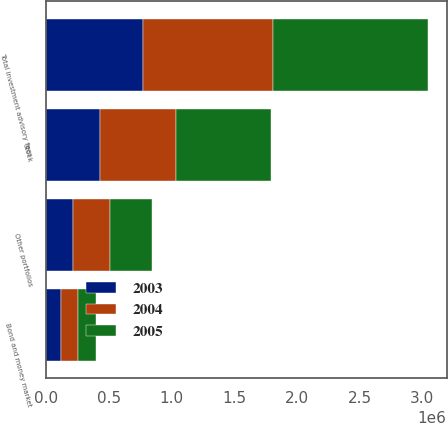Convert chart to OTSL. <chart><loc_0><loc_0><loc_500><loc_500><stacked_bar_chart><ecel><fcel>Stock<fcel>Bond and money market<fcel>Other portfolios<fcel>Total investment advisory fees<nl><fcel>2003<fcel>434423<fcel>123879<fcel>219160<fcel>777462<nl><fcel>2004<fcel>602220<fcel>133953<fcel>292658<fcel>1.02883e+06<nl><fcel>2005<fcel>758346<fcel>142057<fcel>335096<fcel>1.2355e+06<nl></chart> 